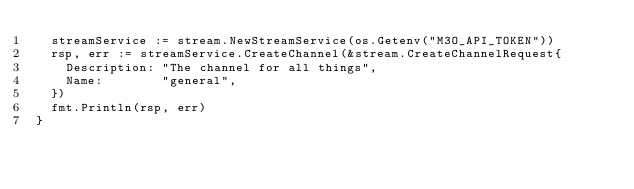Convert code to text. <code><loc_0><loc_0><loc_500><loc_500><_Go_>	streamService := stream.NewStreamService(os.Getenv("M3O_API_TOKEN"))
	rsp, err := streamService.CreateChannel(&stream.CreateChannelRequest{
		Description: "The channel for all things",
		Name:        "general",
	})
	fmt.Println(rsp, err)
}
</code> 